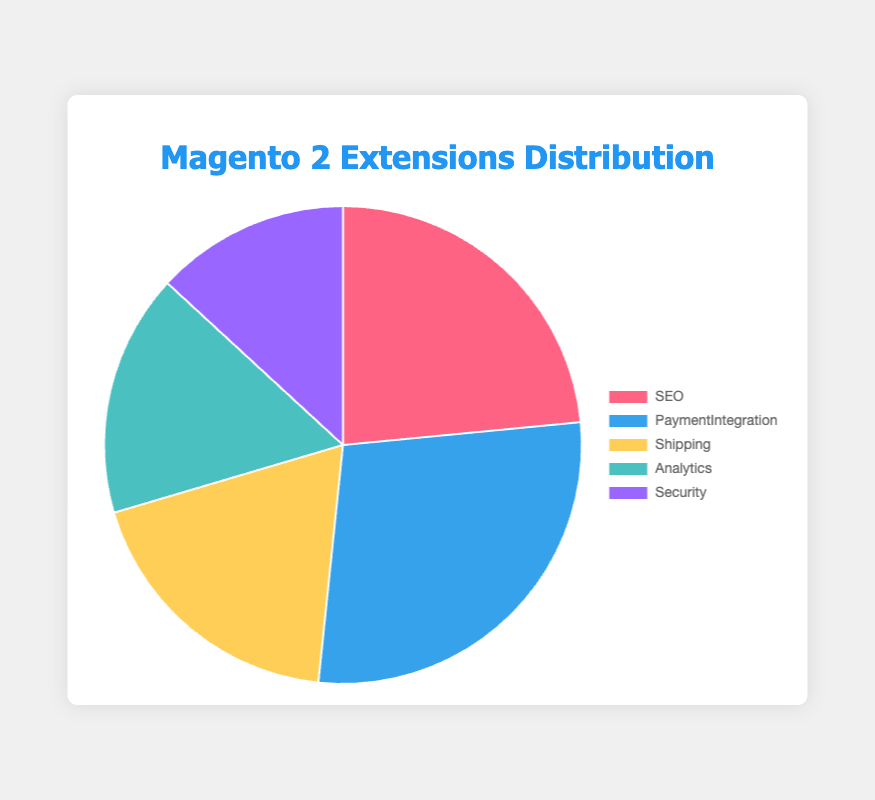What percentage of Magento 2 extensions are SEO-related compared to the total extensions? Sum all the data points of functionalities: 50 (SEO) + 60 (Payment Integration) + 40 (Shipping) + 35 (Analytics) + 28 (Security) = 213. The percentage of SEO-related extensions is (50 / 213) * 100, approximately 23.47%.
Answer: 23.47% Which functionality has the highest number of extensions, and by how much does it exceed the lowest one? The highest functionality is Payment Integration with 60 extensions and the lowest is Security with 28 extensions. The difference is 60 - 28 = 32.
Answer: Payment Integration, by 32 If you combined the extensions for Analytics and Shipping, how does this total compare to Payment Integration? Sum of Analytics and Shipping is 35 + 40 = 75. Compare with Payment Integration which is 60. 75 - 60 = 15 more than Payment Integration.
Answer: 75, 15 more What is the total number of Payment Integration and SEO extensions combined? Sum of Payment Integration and SEO is 60 + 50 = 110.
Answer: 110 What is the proportion of Shipping extensions to the total number of extensions? Total number of extensions is 213. The proportion of Shipping is 40 / 213, approximately 0.188 or 18.8%.
Answer: 18.8% Which functionality's slice in the pie chart is colored yellow? By observing the color coding, the yellow slice represents Shipping.
Answer: Shipping Compare the number of Analytics extensions to Security extensions. Which is higher, and by how much? Analytics has 35 extensions whereas Security has 28. The difference is 35 - 28 = 7.
Answer: Analytics, by 7 Calculate the overall average number of extensions across all functionalities. Sum all data points: 213. Number of functionalities: 5. The average is 213 / 5 = 42.6.
Answer: 42.6 